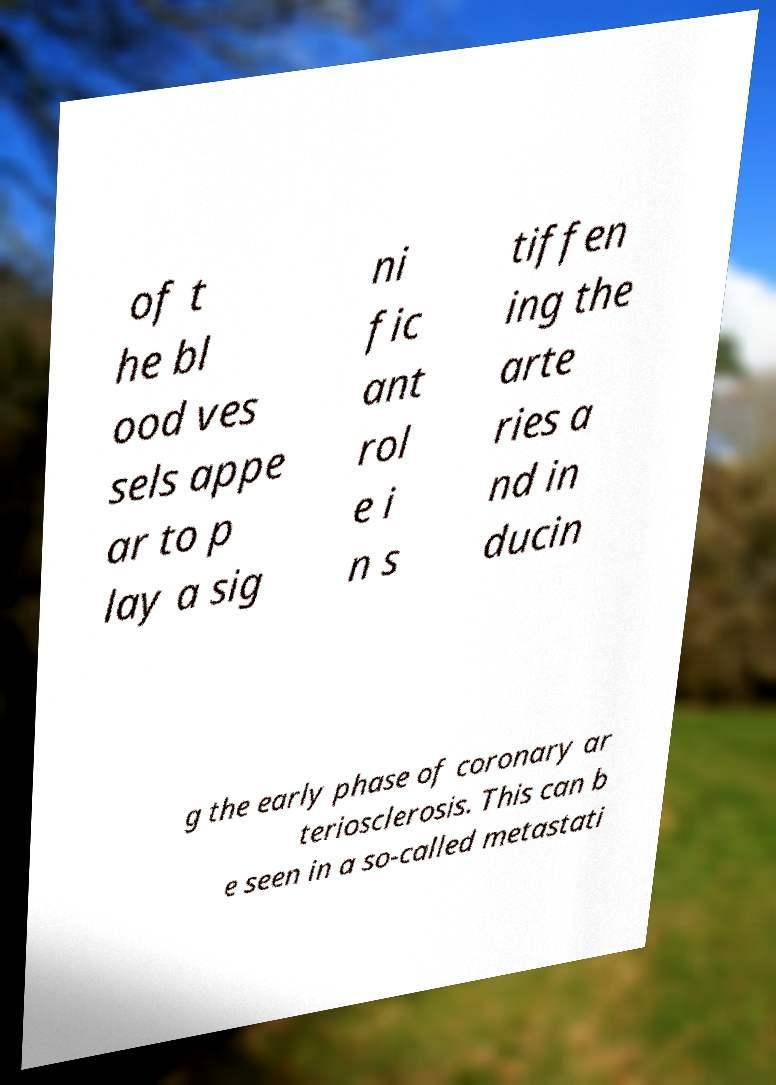Can you read and provide the text displayed in the image?This photo seems to have some interesting text. Can you extract and type it out for me? of t he bl ood ves sels appe ar to p lay a sig ni fic ant rol e i n s tiffen ing the arte ries a nd in ducin g the early phase of coronary ar teriosclerosis. This can b e seen in a so-called metastati 